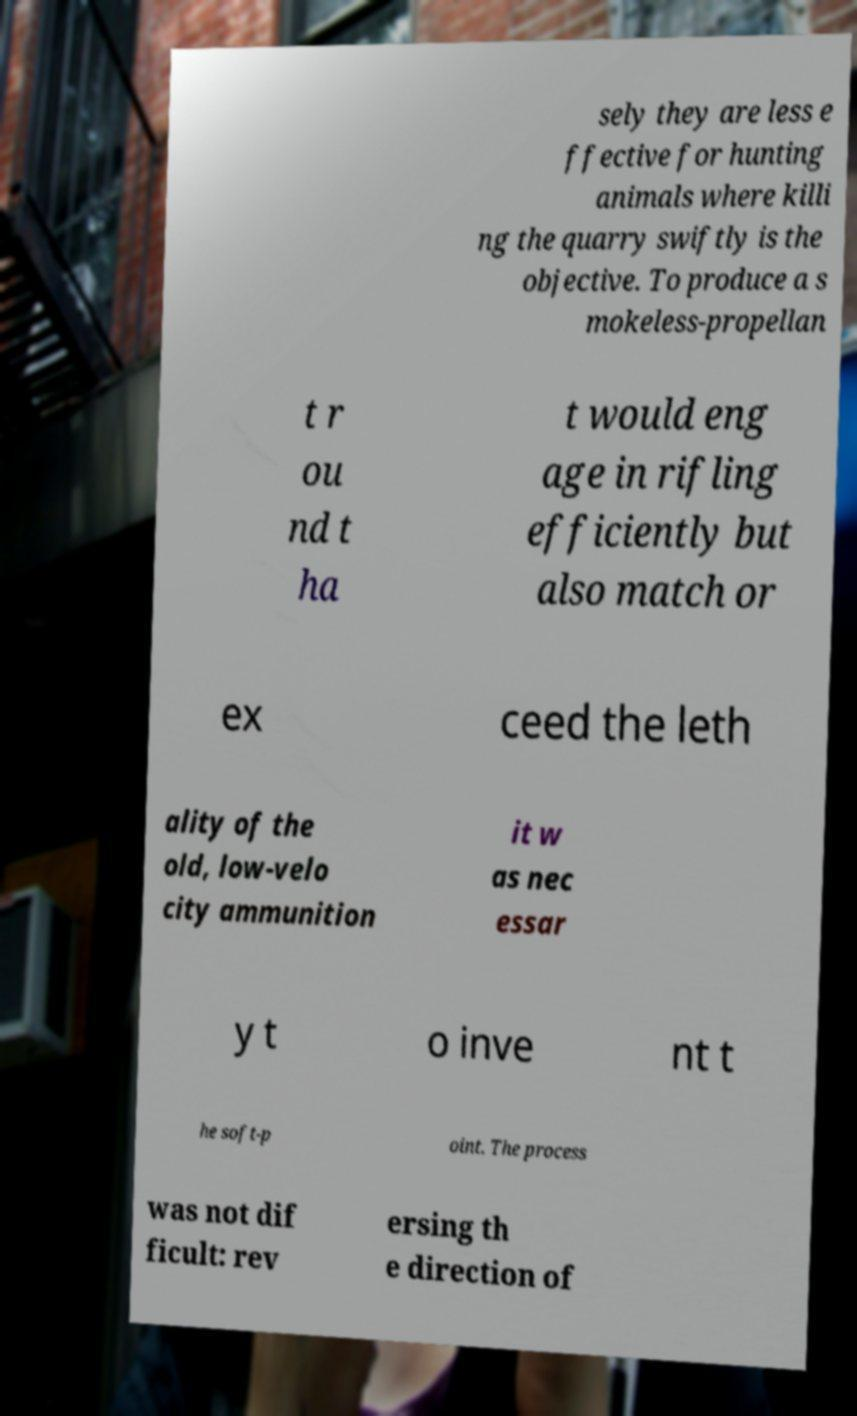Could you extract and type out the text from this image? sely they are less e ffective for hunting animals where killi ng the quarry swiftly is the objective. To produce a s mokeless-propellan t r ou nd t ha t would eng age in rifling efficiently but also match or ex ceed the leth ality of the old, low-velo city ammunition it w as nec essar y t o inve nt t he soft-p oint. The process was not dif ficult: rev ersing th e direction of 